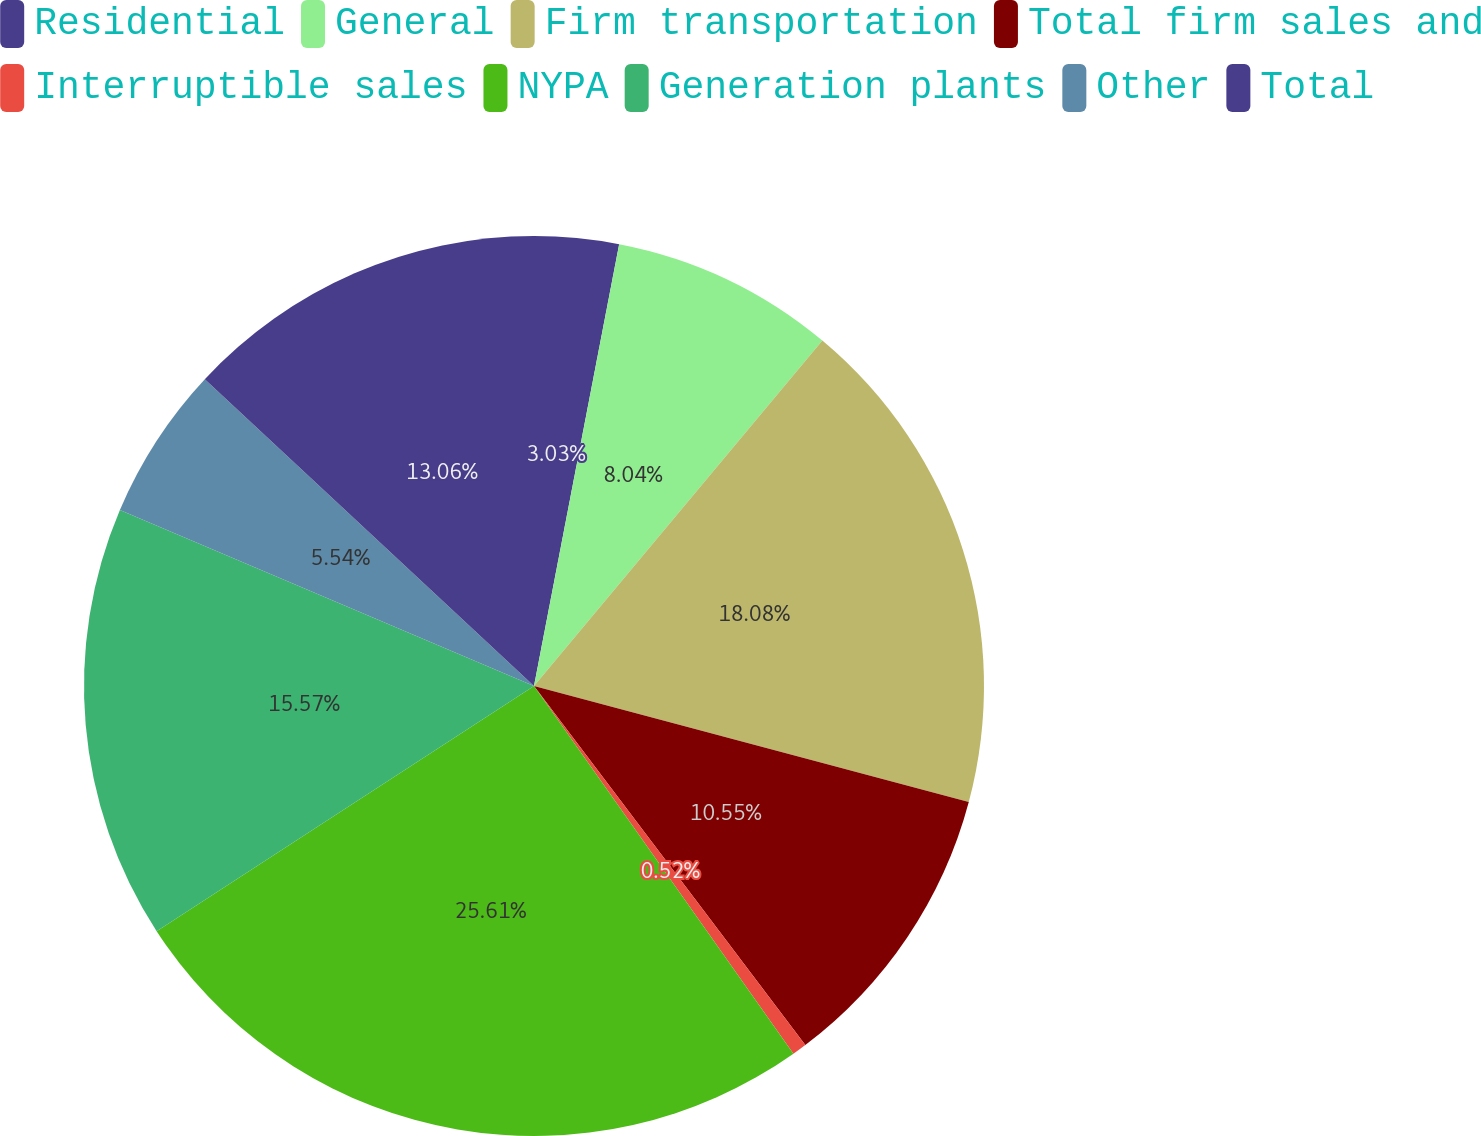<chart> <loc_0><loc_0><loc_500><loc_500><pie_chart><fcel>Residential<fcel>General<fcel>Firm transportation<fcel>Total firm sales and<fcel>Interruptible sales<fcel>NYPA<fcel>Generation plants<fcel>Other<fcel>Total<nl><fcel>3.03%<fcel>8.04%<fcel>18.08%<fcel>10.55%<fcel>0.52%<fcel>25.61%<fcel>15.57%<fcel>5.54%<fcel>13.06%<nl></chart> 